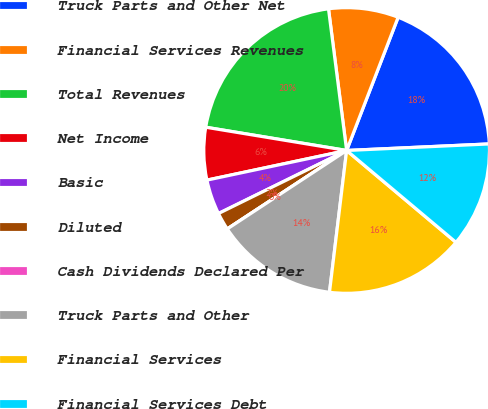<chart> <loc_0><loc_0><loc_500><loc_500><pie_chart><fcel>Truck Parts and Other Net<fcel>Financial Services Revenues<fcel>Total Revenues<fcel>Net Income<fcel>Basic<fcel>Diluted<fcel>Cash Dividends Declared Per<fcel>Truck Parts and Other<fcel>Financial Services<fcel>Financial Services Debt<nl><fcel>18.4%<fcel>7.9%<fcel>20.37%<fcel>5.93%<fcel>3.95%<fcel>1.98%<fcel>0.0%<fcel>13.83%<fcel>15.8%<fcel>11.85%<nl></chart> 